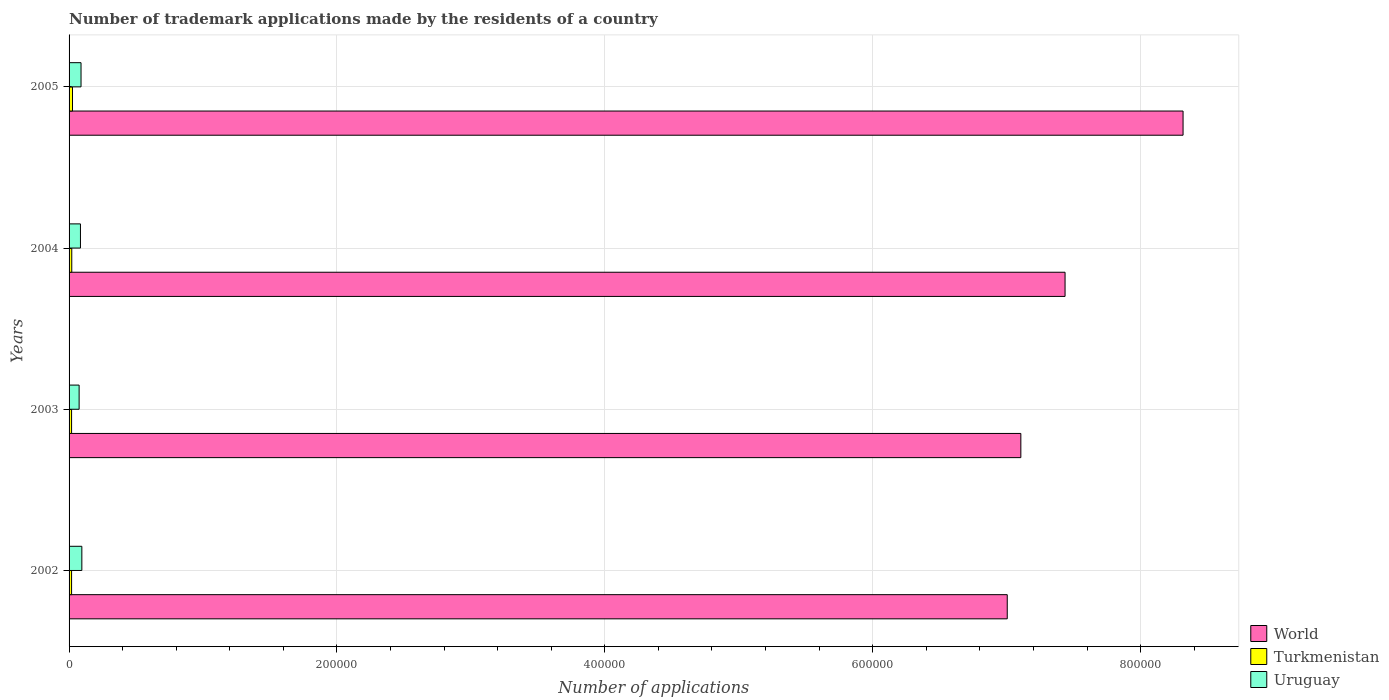Are the number of bars per tick equal to the number of legend labels?
Keep it short and to the point. Yes. Are the number of bars on each tick of the Y-axis equal?
Your response must be concise. Yes. What is the label of the 2nd group of bars from the top?
Offer a terse response. 2004. In how many cases, is the number of bars for a given year not equal to the number of legend labels?
Offer a very short reply. 0. What is the number of trademark applications made by the residents in Uruguay in 2002?
Give a very brief answer. 9533. Across all years, what is the maximum number of trademark applications made by the residents in Uruguay?
Provide a succinct answer. 9533. Across all years, what is the minimum number of trademark applications made by the residents in Uruguay?
Offer a terse response. 7506. In which year was the number of trademark applications made by the residents in Uruguay maximum?
Ensure brevity in your answer.  2002. In which year was the number of trademark applications made by the residents in World minimum?
Your answer should be compact. 2002. What is the total number of trademark applications made by the residents in Uruguay in the graph?
Give a very brief answer. 3.45e+04. What is the difference between the number of trademark applications made by the residents in Uruguay in 2002 and that in 2004?
Keep it short and to the point. 1031. What is the difference between the number of trademark applications made by the residents in World in 2005 and the number of trademark applications made by the residents in Turkmenistan in 2002?
Offer a terse response. 8.30e+05. What is the average number of trademark applications made by the residents in World per year?
Keep it short and to the point. 7.47e+05. In the year 2003, what is the difference between the number of trademark applications made by the residents in World and number of trademark applications made by the residents in Turkmenistan?
Your answer should be compact. 7.09e+05. What is the ratio of the number of trademark applications made by the residents in Uruguay in 2003 to that in 2005?
Your response must be concise. 0.84. What is the difference between the highest and the second highest number of trademark applications made by the residents in Turkmenistan?
Offer a terse response. 552. What is the difference between the highest and the lowest number of trademark applications made by the residents in Uruguay?
Provide a succinct answer. 2027. What does the 1st bar from the top in 2004 represents?
Your response must be concise. Uruguay. What does the 2nd bar from the bottom in 2002 represents?
Ensure brevity in your answer.  Turkmenistan. How many bars are there?
Provide a succinct answer. 12. Are all the bars in the graph horizontal?
Offer a very short reply. Yes. How many years are there in the graph?
Keep it short and to the point. 4. Does the graph contain any zero values?
Provide a short and direct response. No. How many legend labels are there?
Your answer should be compact. 3. How are the legend labels stacked?
Offer a terse response. Vertical. What is the title of the graph?
Your answer should be compact. Number of trademark applications made by the residents of a country. Does "Luxembourg" appear as one of the legend labels in the graph?
Make the answer very short. No. What is the label or title of the X-axis?
Provide a succinct answer. Number of applications. What is the Number of applications in World in 2002?
Provide a succinct answer. 7.00e+05. What is the Number of applications in Turkmenistan in 2002?
Give a very brief answer. 1869. What is the Number of applications in Uruguay in 2002?
Offer a very short reply. 9533. What is the Number of applications in World in 2003?
Provide a succinct answer. 7.11e+05. What is the Number of applications of Turkmenistan in 2003?
Offer a very short reply. 1876. What is the Number of applications in Uruguay in 2003?
Provide a short and direct response. 7506. What is the Number of applications in World in 2004?
Your answer should be very brief. 7.44e+05. What is the Number of applications of Turkmenistan in 2004?
Make the answer very short. 2013. What is the Number of applications of Uruguay in 2004?
Ensure brevity in your answer.  8502. What is the Number of applications of World in 2005?
Offer a terse response. 8.32e+05. What is the Number of applications of Turkmenistan in 2005?
Make the answer very short. 2565. What is the Number of applications of Uruguay in 2005?
Make the answer very short. 8930. Across all years, what is the maximum Number of applications of World?
Make the answer very short. 8.32e+05. Across all years, what is the maximum Number of applications of Turkmenistan?
Your answer should be very brief. 2565. Across all years, what is the maximum Number of applications in Uruguay?
Your response must be concise. 9533. Across all years, what is the minimum Number of applications of World?
Keep it short and to the point. 7.00e+05. Across all years, what is the minimum Number of applications in Turkmenistan?
Make the answer very short. 1869. Across all years, what is the minimum Number of applications in Uruguay?
Keep it short and to the point. 7506. What is the total Number of applications of World in the graph?
Make the answer very short. 2.99e+06. What is the total Number of applications of Turkmenistan in the graph?
Your answer should be very brief. 8323. What is the total Number of applications of Uruguay in the graph?
Keep it short and to the point. 3.45e+04. What is the difference between the Number of applications of World in 2002 and that in 2003?
Keep it short and to the point. -1.02e+04. What is the difference between the Number of applications of Turkmenistan in 2002 and that in 2003?
Offer a very short reply. -7. What is the difference between the Number of applications in Uruguay in 2002 and that in 2003?
Provide a succinct answer. 2027. What is the difference between the Number of applications of World in 2002 and that in 2004?
Provide a short and direct response. -4.32e+04. What is the difference between the Number of applications of Turkmenistan in 2002 and that in 2004?
Provide a succinct answer. -144. What is the difference between the Number of applications of Uruguay in 2002 and that in 2004?
Your response must be concise. 1031. What is the difference between the Number of applications of World in 2002 and that in 2005?
Offer a very short reply. -1.31e+05. What is the difference between the Number of applications of Turkmenistan in 2002 and that in 2005?
Ensure brevity in your answer.  -696. What is the difference between the Number of applications in Uruguay in 2002 and that in 2005?
Keep it short and to the point. 603. What is the difference between the Number of applications of World in 2003 and that in 2004?
Offer a very short reply. -3.30e+04. What is the difference between the Number of applications of Turkmenistan in 2003 and that in 2004?
Provide a succinct answer. -137. What is the difference between the Number of applications in Uruguay in 2003 and that in 2004?
Provide a succinct answer. -996. What is the difference between the Number of applications in World in 2003 and that in 2005?
Your answer should be very brief. -1.21e+05. What is the difference between the Number of applications of Turkmenistan in 2003 and that in 2005?
Give a very brief answer. -689. What is the difference between the Number of applications of Uruguay in 2003 and that in 2005?
Your answer should be compact. -1424. What is the difference between the Number of applications in World in 2004 and that in 2005?
Provide a succinct answer. -8.81e+04. What is the difference between the Number of applications of Turkmenistan in 2004 and that in 2005?
Make the answer very short. -552. What is the difference between the Number of applications of Uruguay in 2004 and that in 2005?
Keep it short and to the point. -428. What is the difference between the Number of applications of World in 2002 and the Number of applications of Turkmenistan in 2003?
Your answer should be very brief. 6.99e+05. What is the difference between the Number of applications of World in 2002 and the Number of applications of Uruguay in 2003?
Provide a short and direct response. 6.93e+05. What is the difference between the Number of applications of Turkmenistan in 2002 and the Number of applications of Uruguay in 2003?
Give a very brief answer. -5637. What is the difference between the Number of applications in World in 2002 and the Number of applications in Turkmenistan in 2004?
Make the answer very short. 6.98e+05. What is the difference between the Number of applications of World in 2002 and the Number of applications of Uruguay in 2004?
Your response must be concise. 6.92e+05. What is the difference between the Number of applications of Turkmenistan in 2002 and the Number of applications of Uruguay in 2004?
Offer a terse response. -6633. What is the difference between the Number of applications in World in 2002 and the Number of applications in Turkmenistan in 2005?
Provide a short and direct response. 6.98e+05. What is the difference between the Number of applications in World in 2002 and the Number of applications in Uruguay in 2005?
Offer a very short reply. 6.92e+05. What is the difference between the Number of applications in Turkmenistan in 2002 and the Number of applications in Uruguay in 2005?
Offer a terse response. -7061. What is the difference between the Number of applications of World in 2003 and the Number of applications of Turkmenistan in 2004?
Provide a succinct answer. 7.09e+05. What is the difference between the Number of applications of World in 2003 and the Number of applications of Uruguay in 2004?
Offer a very short reply. 7.02e+05. What is the difference between the Number of applications of Turkmenistan in 2003 and the Number of applications of Uruguay in 2004?
Your answer should be compact. -6626. What is the difference between the Number of applications in World in 2003 and the Number of applications in Turkmenistan in 2005?
Provide a short and direct response. 7.08e+05. What is the difference between the Number of applications of World in 2003 and the Number of applications of Uruguay in 2005?
Keep it short and to the point. 7.02e+05. What is the difference between the Number of applications in Turkmenistan in 2003 and the Number of applications in Uruguay in 2005?
Keep it short and to the point. -7054. What is the difference between the Number of applications of World in 2004 and the Number of applications of Turkmenistan in 2005?
Your answer should be very brief. 7.41e+05. What is the difference between the Number of applications of World in 2004 and the Number of applications of Uruguay in 2005?
Offer a terse response. 7.35e+05. What is the difference between the Number of applications in Turkmenistan in 2004 and the Number of applications in Uruguay in 2005?
Your answer should be very brief. -6917. What is the average Number of applications of World per year?
Provide a succinct answer. 7.47e+05. What is the average Number of applications of Turkmenistan per year?
Provide a short and direct response. 2080.75. What is the average Number of applications in Uruguay per year?
Give a very brief answer. 8617.75. In the year 2002, what is the difference between the Number of applications of World and Number of applications of Turkmenistan?
Give a very brief answer. 6.99e+05. In the year 2002, what is the difference between the Number of applications in World and Number of applications in Uruguay?
Your answer should be very brief. 6.91e+05. In the year 2002, what is the difference between the Number of applications in Turkmenistan and Number of applications in Uruguay?
Keep it short and to the point. -7664. In the year 2003, what is the difference between the Number of applications in World and Number of applications in Turkmenistan?
Your response must be concise. 7.09e+05. In the year 2003, what is the difference between the Number of applications in World and Number of applications in Uruguay?
Make the answer very short. 7.03e+05. In the year 2003, what is the difference between the Number of applications of Turkmenistan and Number of applications of Uruguay?
Offer a terse response. -5630. In the year 2004, what is the difference between the Number of applications of World and Number of applications of Turkmenistan?
Your answer should be very brief. 7.42e+05. In the year 2004, what is the difference between the Number of applications in World and Number of applications in Uruguay?
Provide a succinct answer. 7.35e+05. In the year 2004, what is the difference between the Number of applications in Turkmenistan and Number of applications in Uruguay?
Your answer should be very brief. -6489. In the year 2005, what is the difference between the Number of applications in World and Number of applications in Turkmenistan?
Give a very brief answer. 8.29e+05. In the year 2005, what is the difference between the Number of applications of World and Number of applications of Uruguay?
Your response must be concise. 8.23e+05. In the year 2005, what is the difference between the Number of applications in Turkmenistan and Number of applications in Uruguay?
Your response must be concise. -6365. What is the ratio of the Number of applications of World in 2002 to that in 2003?
Offer a terse response. 0.99. What is the ratio of the Number of applications in Turkmenistan in 2002 to that in 2003?
Your answer should be very brief. 1. What is the ratio of the Number of applications of Uruguay in 2002 to that in 2003?
Keep it short and to the point. 1.27. What is the ratio of the Number of applications of World in 2002 to that in 2004?
Your answer should be very brief. 0.94. What is the ratio of the Number of applications in Turkmenistan in 2002 to that in 2004?
Provide a short and direct response. 0.93. What is the ratio of the Number of applications of Uruguay in 2002 to that in 2004?
Your answer should be compact. 1.12. What is the ratio of the Number of applications in World in 2002 to that in 2005?
Give a very brief answer. 0.84. What is the ratio of the Number of applications of Turkmenistan in 2002 to that in 2005?
Your response must be concise. 0.73. What is the ratio of the Number of applications in Uruguay in 2002 to that in 2005?
Give a very brief answer. 1.07. What is the ratio of the Number of applications of World in 2003 to that in 2004?
Provide a succinct answer. 0.96. What is the ratio of the Number of applications in Turkmenistan in 2003 to that in 2004?
Your answer should be compact. 0.93. What is the ratio of the Number of applications in Uruguay in 2003 to that in 2004?
Your response must be concise. 0.88. What is the ratio of the Number of applications of World in 2003 to that in 2005?
Offer a terse response. 0.85. What is the ratio of the Number of applications in Turkmenistan in 2003 to that in 2005?
Ensure brevity in your answer.  0.73. What is the ratio of the Number of applications in Uruguay in 2003 to that in 2005?
Your answer should be compact. 0.84. What is the ratio of the Number of applications in World in 2004 to that in 2005?
Give a very brief answer. 0.89. What is the ratio of the Number of applications in Turkmenistan in 2004 to that in 2005?
Your answer should be compact. 0.78. What is the ratio of the Number of applications of Uruguay in 2004 to that in 2005?
Your answer should be compact. 0.95. What is the difference between the highest and the second highest Number of applications of World?
Provide a short and direct response. 8.81e+04. What is the difference between the highest and the second highest Number of applications in Turkmenistan?
Give a very brief answer. 552. What is the difference between the highest and the second highest Number of applications of Uruguay?
Your response must be concise. 603. What is the difference between the highest and the lowest Number of applications in World?
Ensure brevity in your answer.  1.31e+05. What is the difference between the highest and the lowest Number of applications in Turkmenistan?
Ensure brevity in your answer.  696. What is the difference between the highest and the lowest Number of applications in Uruguay?
Keep it short and to the point. 2027. 